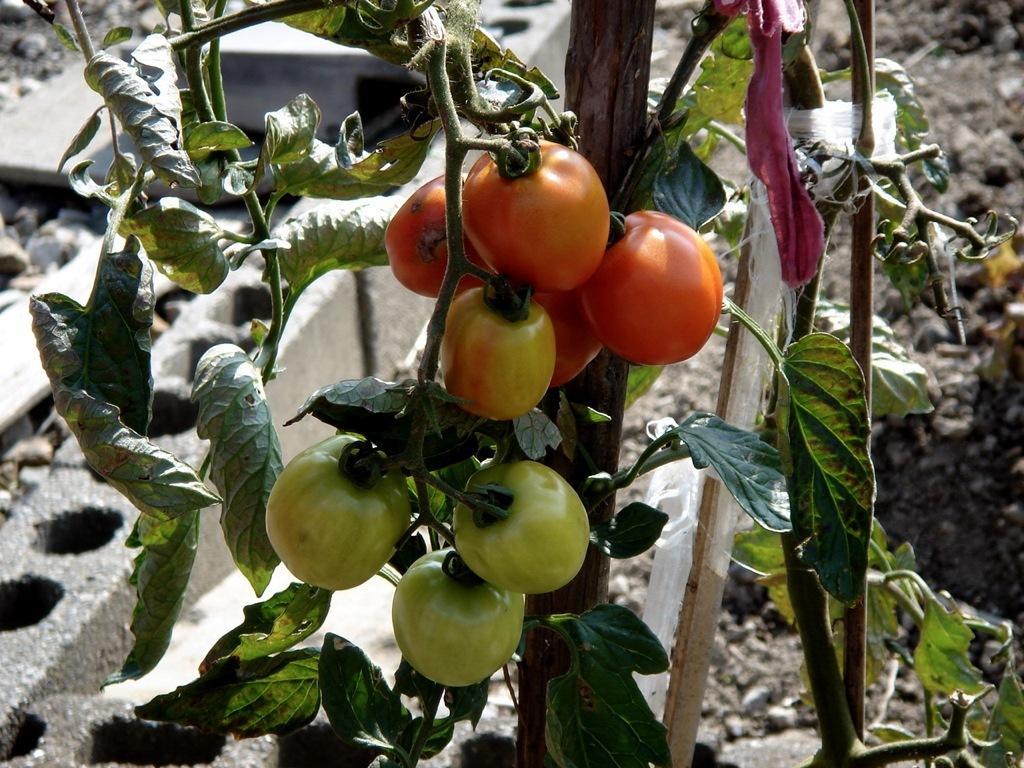Describe this image in one or two sentences. In the center of the image we can see the tomatoes, plant, sticks, cloth. In the background of the image we can see the rocks and mud. 